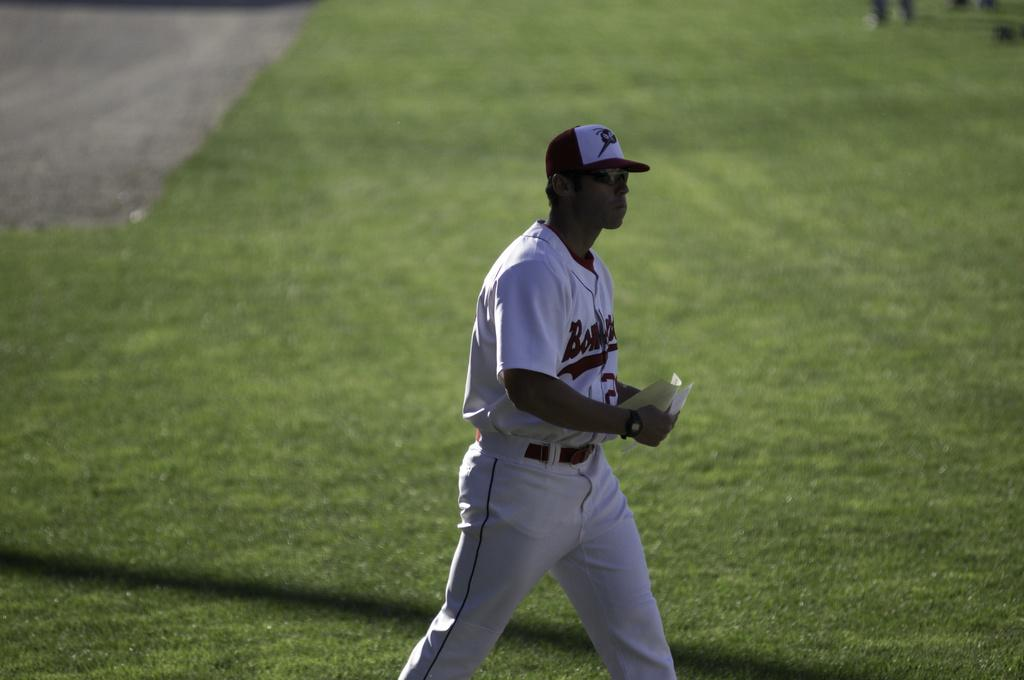<image>
Create a compact narrative representing the image presented. a person in a jersey with the letter B on it walks on a field 